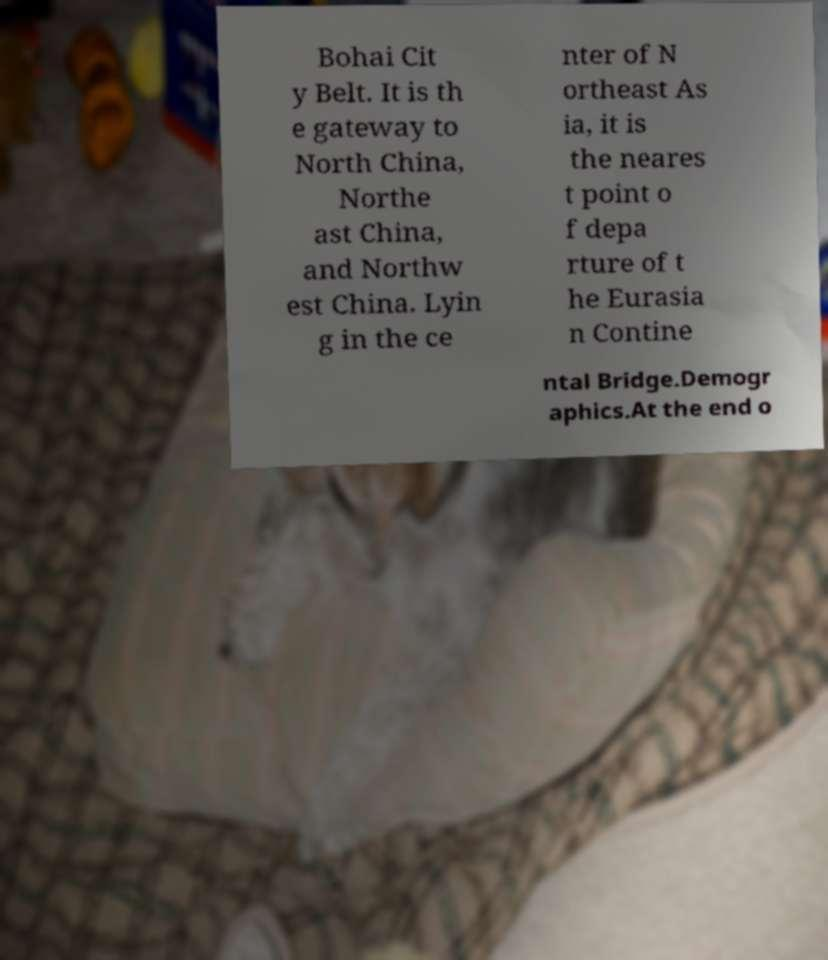For documentation purposes, I need the text within this image transcribed. Could you provide that? Bohai Cit y Belt. It is th e gateway to North China, Northe ast China, and Northw est China. Lyin g in the ce nter of N ortheast As ia, it is the neares t point o f depa rture of t he Eurasia n Contine ntal Bridge.Demogr aphics.At the end o 